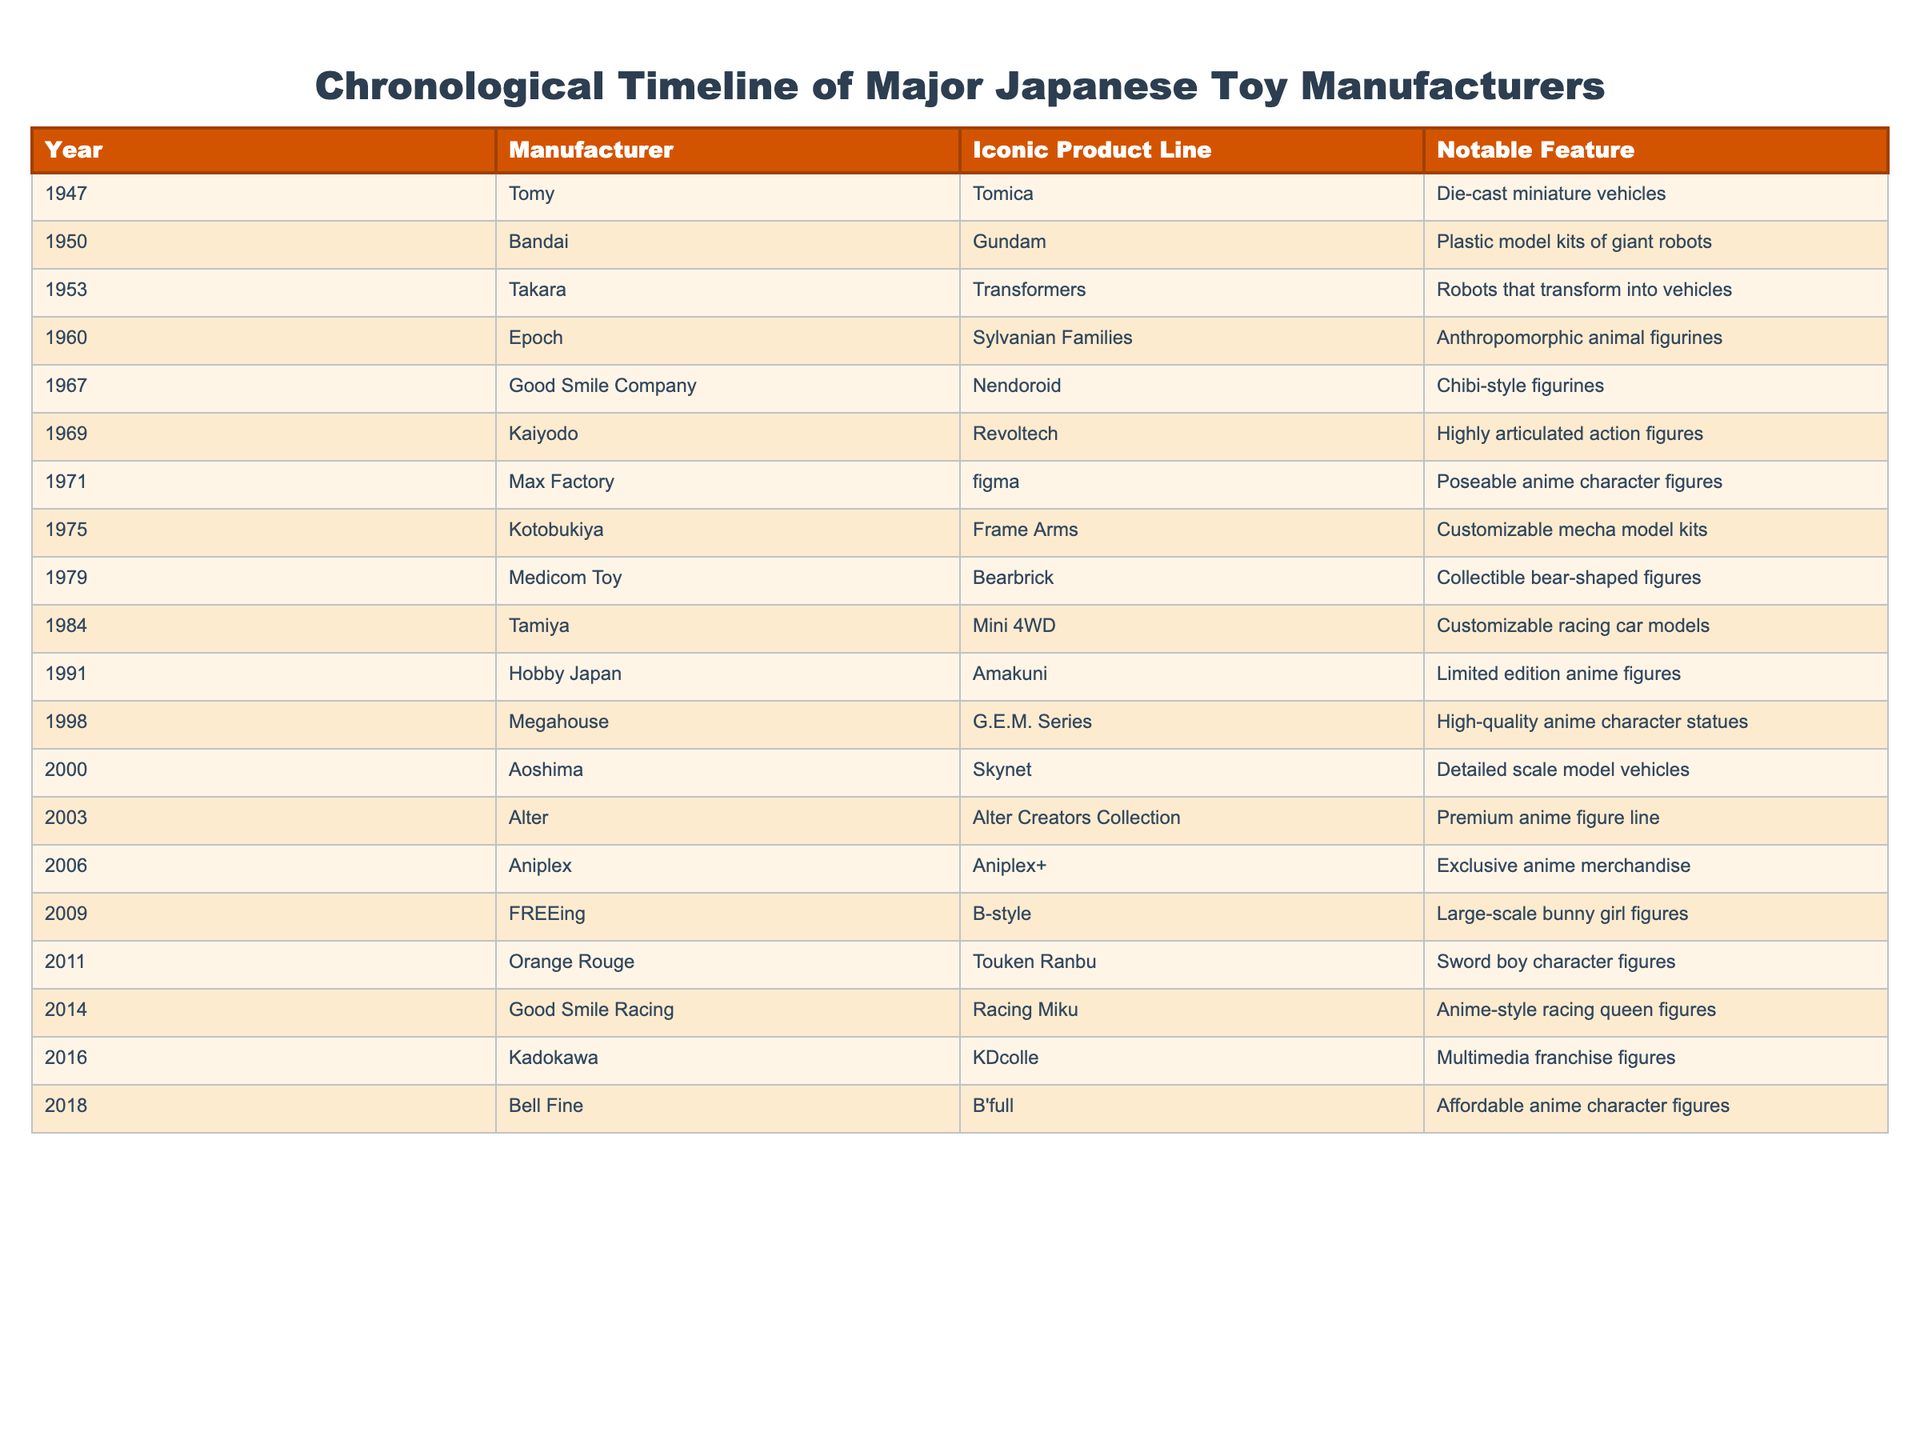What year did Tomy release the Tomica line? According to the table, Tomy released the Tomica line in 1947.
Answer: 1947 Which manufacturer is known for the G.E.M. Series? The manufacturer known for the G.E.M. Series is Megahouse, as indicated in the table.
Answer: Megahouse What is the notable feature of the Sylvanian Families product line? The notable feature of the Sylvanian Families product line is anthropomorphic animal figurines, as stated in the table.
Answer: Anthropomorphic animal figurines How many manufacturers released their iconic product lines in the 2000s? Looking at the table, there are three manufacturers (Aoshima, Alter, and Aniplex) that released their lines in the 2000s, which are from the years 2000, 2003, and 2006 respectively.
Answer: 3 Which product line was introduced first, Bearbrick or Mini 4WD? Bearbrick was introduced in 1979 and Mini 4WD in 1984, making Bearbrick the earlier product line based on the years from the table.
Answer: Bearbrick Is Good Smile Company associated with the Nendoroid product line? The table confirms that Good Smile Company is indeed associated with the Nendoroid product line.
Answer: Yes What is the difference in years between the release of the Frame Arms and the G.E.M. Series? Frame Arms was released in 1975 and G.E.M. Series in 1998. The difference in years is calculated as 1998 - 1975 = 23 years.
Answer: 23 years Which product line has the notable feature of being customizable racing car models? The Mini 4WD product line by Tamiya has the notable feature of being customizable racing car models according to the table.
Answer: Mini 4WD Which manufacturer has released more than one iconic product line? Bandai has been known for Gundam (1950) and is also associated with different series, but in this table specifically, it appears to have only one entry. However, if considering other data, multiple lines could include the likes of Tomy with Tomica and other products over the years. Based solely on this table, we see no manufacturer has multiple entries. Thus, no single manufacturer can be confirmed as having done so in the provided list.
Answer: No What is the notable feature of the Alter Creators Collection? The notable feature of the Alter Creators Collection is a premium anime figure line, as noted in the table.
Answer: Premium anime figure line 